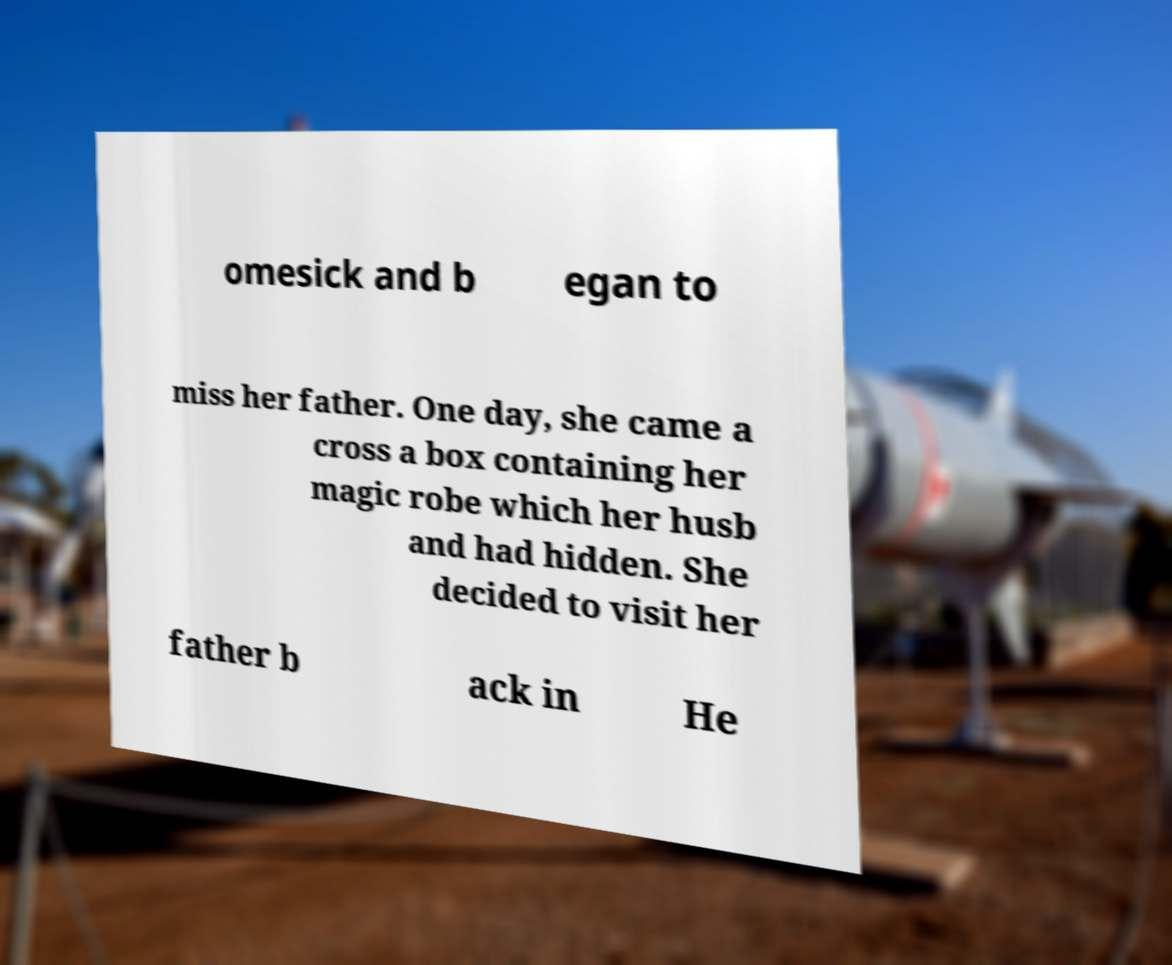I need the written content from this picture converted into text. Can you do that? omesick and b egan to miss her father. One day, she came a cross a box containing her magic robe which her husb and had hidden. She decided to visit her father b ack in He 